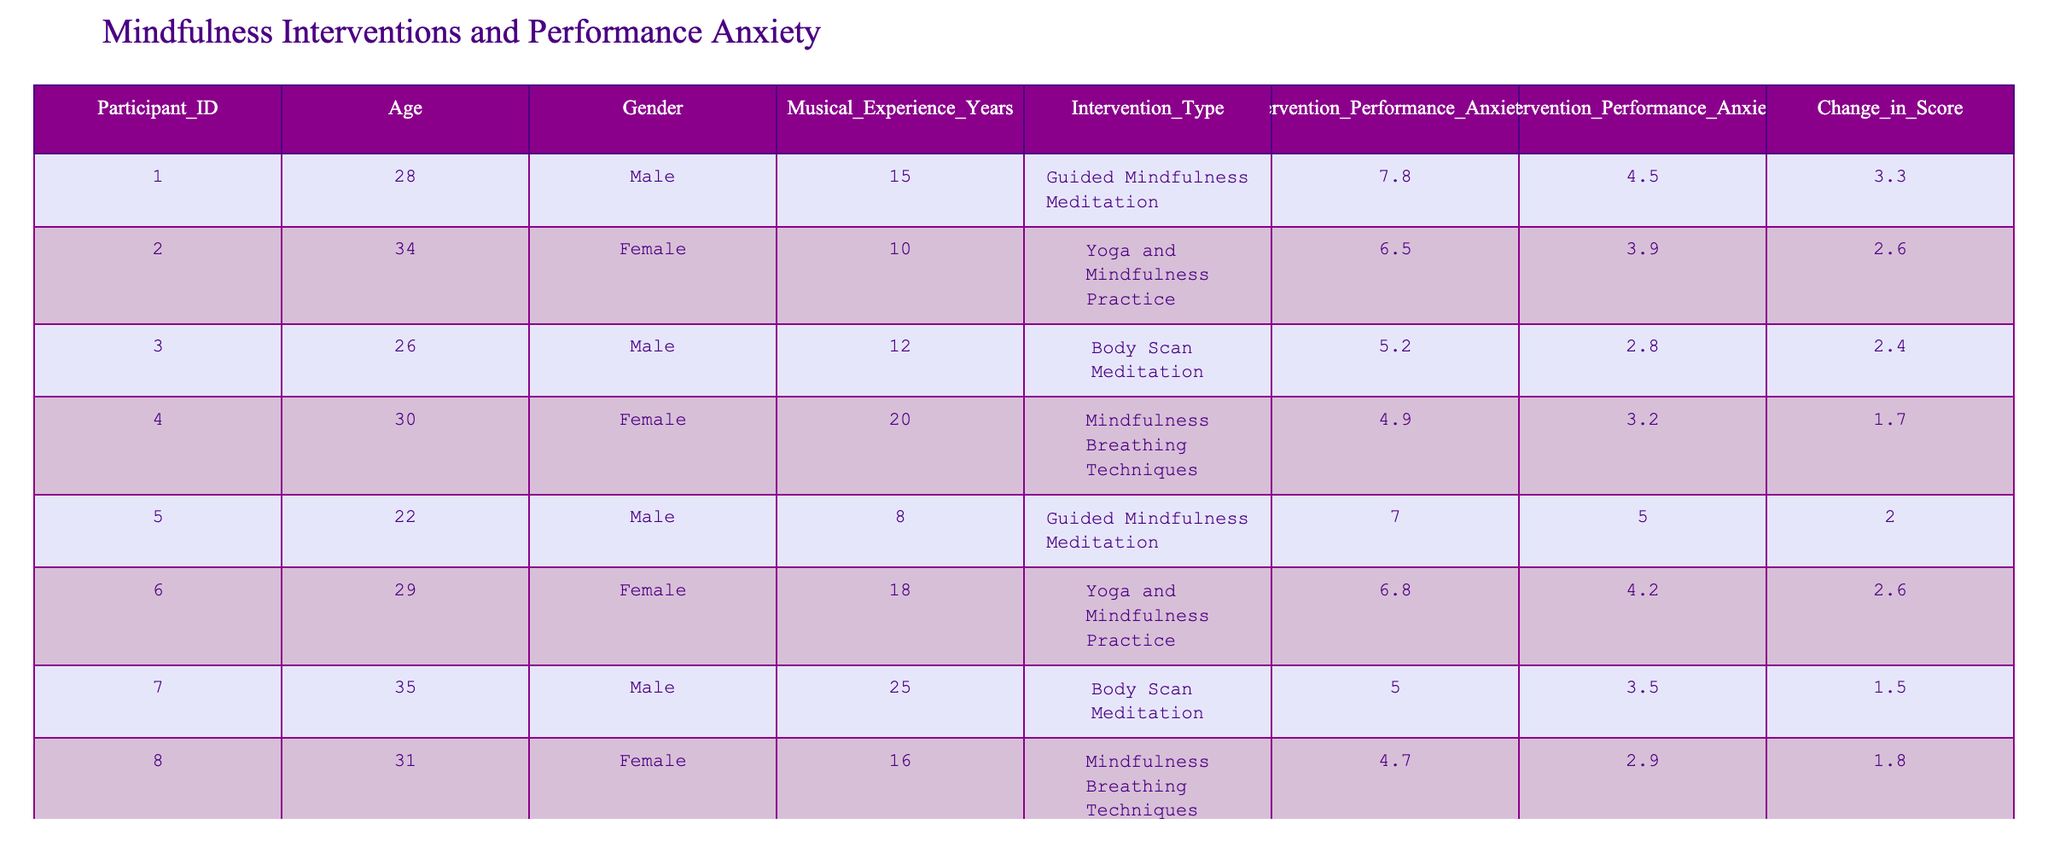What was the highest Pre-Intervention Performance Anxiety Score recorded? Looking through the table, I identify the Pre-Intervention Performance Anxiety Scores for all participants. The highest score is 7.8 from participant 001.
Answer: 7.8 Which intervention led to the least change in performance anxiety score? By examining the "Change in Score" column, the lowest change is 1.5, which corresponds to participant 007 who underwent Body Scan Meditation.
Answer: Body Scan Meditation What is the average change in performance anxiety score across all participants? To calculate the average change, I sum all the changes: (3.3 + 2.6 + 2.4 + 1.7 + 2.0 + 2.6 + 1.5 + 1.8) = 18.9. There are 8 participants, so the average is 18.9 / 8 = 2.3625, which can round to 2.36.
Answer: 2.36 Is there any participant who showed no change or an increase in their performance anxiety score? I examine the "Change in Score" column but find all values to be positive, indicating a decrease for all participants. Therefore, there are no cases of no change or an increase.
Answer: No What percentage of participants experienced a change greater than 2? Analyzing the "Change in Score" column, I find that participants 001, 002, 003, 005, and 006 experienced changes greater than 2, which accounts for 5 out of 8 participants. Therefore, the percentage is (5/8) * 100 = 62.5%.
Answer: 62.5% Which gender showed a greater average decrease in performance anxiety? Calculating the average change for males (3.3 + 2.0 + 2.4 + 1.5 = 9.2) gives 9.2/4 = 2.3, while for females (2.6 + 1.7 + 2.6 + 1.8 = 8.7) gives 8.7/4 = 2.175. The average decrease is greater for males.
Answer: Males What was the Pre-Intervention Performance Anxiety Score of the participant with the most musical experience? I check the "Musical Experience Years" column and find participant 007 with 25 years of experience. Their Pre-Intervention Score is 5.0.
Answer: 5.0 Did any individual participant experience a reduction in their score of exactly 2.6? I review the "Change in Score" column and find that participant 002 showed a reduction of 2.6.
Answer: Yes 